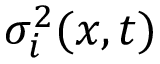<formula> <loc_0><loc_0><loc_500><loc_500>\sigma _ { i } ^ { 2 } ( x , t )</formula> 